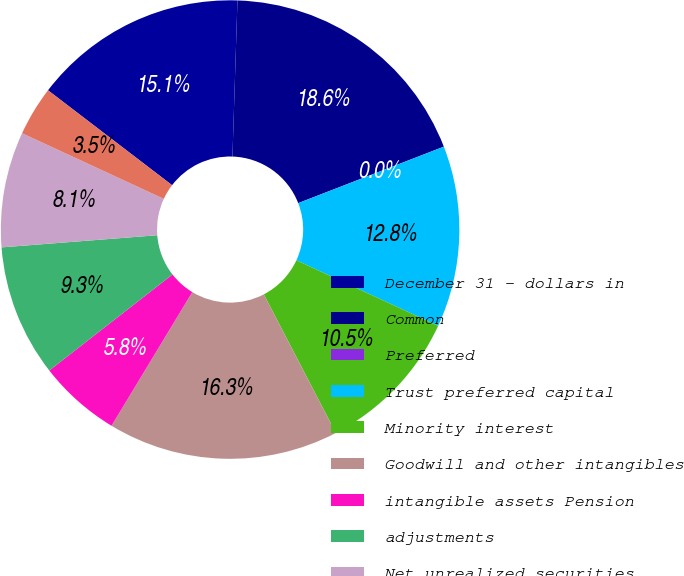<chart> <loc_0><loc_0><loc_500><loc_500><pie_chart><fcel>December 31 - dollars in<fcel>Common<fcel>Preferred<fcel>Trust preferred capital<fcel>Minority interest<fcel>Goodwill and other intangibles<fcel>intangible assets Pension<fcel>adjustments<fcel>Net unrealized securities<fcel>Net unrealized losses (gains)<nl><fcel>15.12%<fcel>18.6%<fcel>0.0%<fcel>12.79%<fcel>10.47%<fcel>16.28%<fcel>5.81%<fcel>9.3%<fcel>8.14%<fcel>3.49%<nl></chart> 